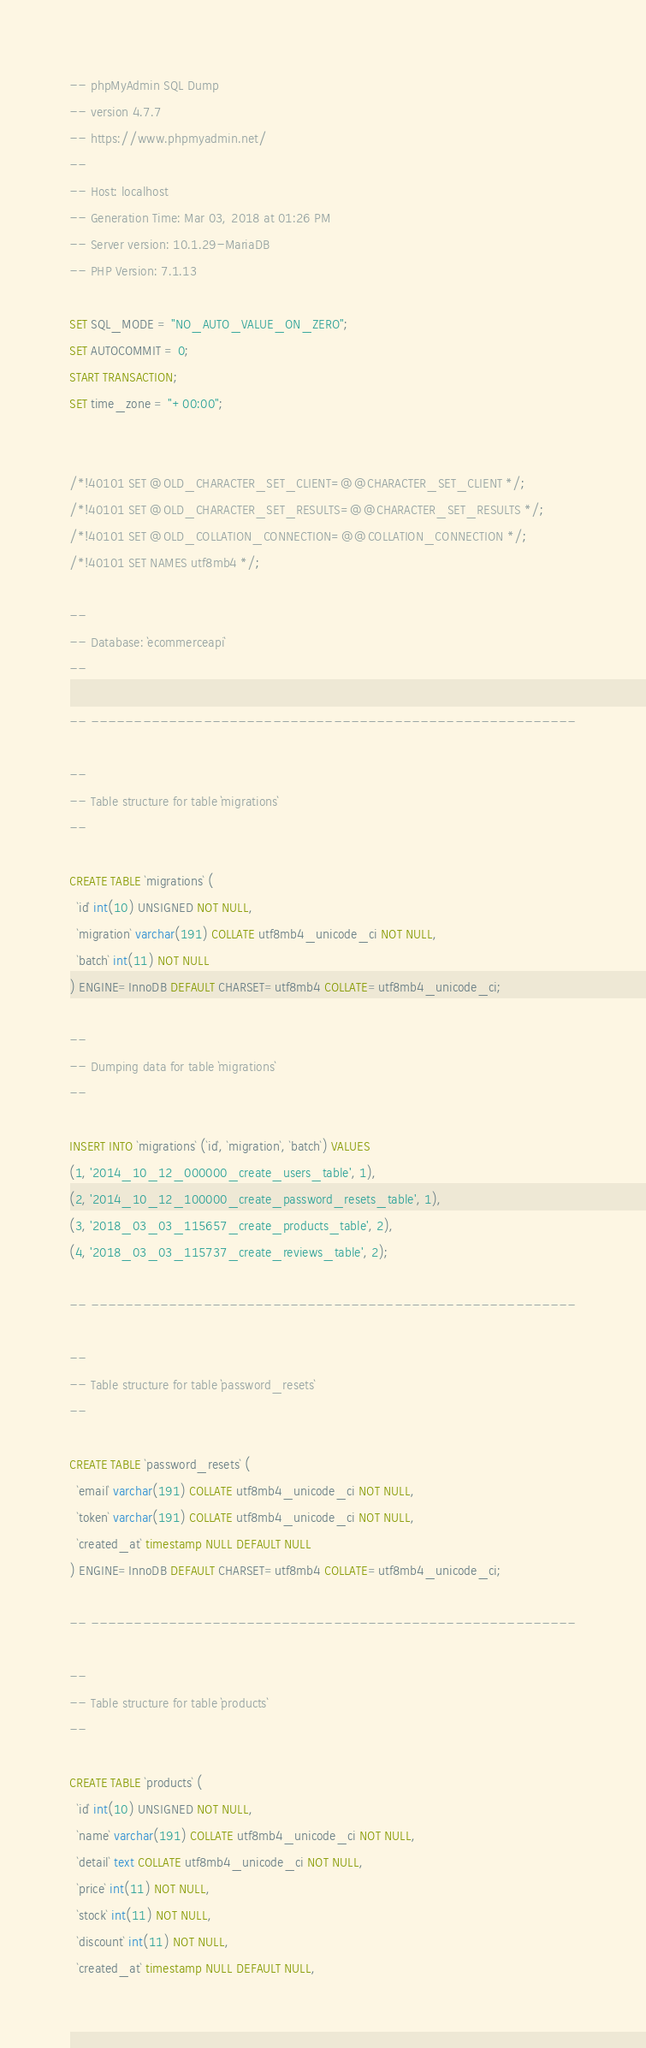Convert code to text. <code><loc_0><loc_0><loc_500><loc_500><_SQL_>-- phpMyAdmin SQL Dump
-- version 4.7.7
-- https://www.phpmyadmin.net/
--
-- Host: localhost
-- Generation Time: Mar 03, 2018 at 01:26 PM
-- Server version: 10.1.29-MariaDB
-- PHP Version: 7.1.13

SET SQL_MODE = "NO_AUTO_VALUE_ON_ZERO";
SET AUTOCOMMIT = 0;
START TRANSACTION;
SET time_zone = "+00:00";


/*!40101 SET @OLD_CHARACTER_SET_CLIENT=@@CHARACTER_SET_CLIENT */;
/*!40101 SET @OLD_CHARACTER_SET_RESULTS=@@CHARACTER_SET_RESULTS */;
/*!40101 SET @OLD_COLLATION_CONNECTION=@@COLLATION_CONNECTION */;
/*!40101 SET NAMES utf8mb4 */;

--
-- Database: `ecommerceapi`
--

-- --------------------------------------------------------

--
-- Table structure for table `migrations`
--

CREATE TABLE `migrations` (
  `id` int(10) UNSIGNED NOT NULL,
  `migration` varchar(191) COLLATE utf8mb4_unicode_ci NOT NULL,
  `batch` int(11) NOT NULL
) ENGINE=InnoDB DEFAULT CHARSET=utf8mb4 COLLATE=utf8mb4_unicode_ci;

--
-- Dumping data for table `migrations`
--

INSERT INTO `migrations` (`id`, `migration`, `batch`) VALUES
(1, '2014_10_12_000000_create_users_table', 1),
(2, '2014_10_12_100000_create_password_resets_table', 1),
(3, '2018_03_03_115657_create_products_table', 2),
(4, '2018_03_03_115737_create_reviews_table', 2);

-- --------------------------------------------------------

--
-- Table structure for table `password_resets`
--

CREATE TABLE `password_resets` (
  `email` varchar(191) COLLATE utf8mb4_unicode_ci NOT NULL,
  `token` varchar(191) COLLATE utf8mb4_unicode_ci NOT NULL,
  `created_at` timestamp NULL DEFAULT NULL
) ENGINE=InnoDB DEFAULT CHARSET=utf8mb4 COLLATE=utf8mb4_unicode_ci;

-- --------------------------------------------------------

--
-- Table structure for table `products`
--

CREATE TABLE `products` (
  `id` int(10) UNSIGNED NOT NULL,
  `name` varchar(191) COLLATE utf8mb4_unicode_ci NOT NULL,
  `detail` text COLLATE utf8mb4_unicode_ci NOT NULL,
  `price` int(11) NOT NULL,
  `stock` int(11) NOT NULL,
  `discount` int(11) NOT NULL,
  `created_at` timestamp NULL DEFAULT NULL,</code> 